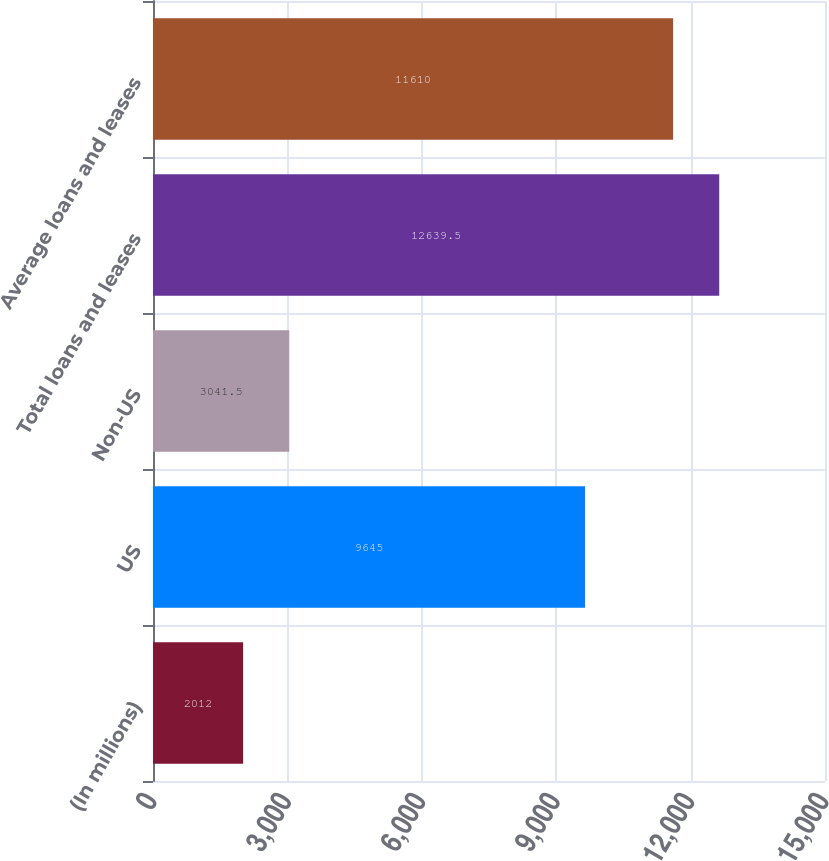<chart> <loc_0><loc_0><loc_500><loc_500><bar_chart><fcel>(In millions)<fcel>US<fcel>Non-US<fcel>Total loans and leases<fcel>Average loans and leases<nl><fcel>2012<fcel>9645<fcel>3041.5<fcel>12639.5<fcel>11610<nl></chart> 